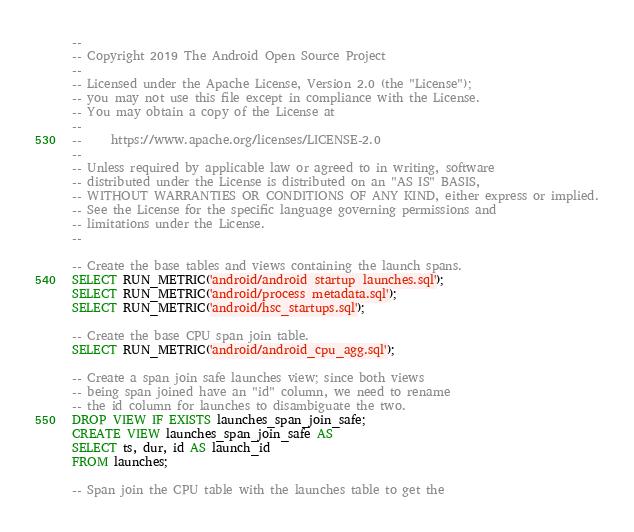<code> <loc_0><loc_0><loc_500><loc_500><_SQL_>--
-- Copyright 2019 The Android Open Source Project
--
-- Licensed under the Apache License, Version 2.0 (the "License");
-- you may not use this file except in compliance with the License.
-- You may obtain a copy of the License at
--
--     https://www.apache.org/licenses/LICENSE-2.0
--
-- Unless required by applicable law or agreed to in writing, software
-- distributed under the License is distributed on an "AS IS" BASIS,
-- WITHOUT WARRANTIES OR CONDITIONS OF ANY KIND, either express or implied.
-- See the License for the specific language governing permissions and
-- limitations under the License.
--

-- Create the base tables and views containing the launch spans.
SELECT RUN_METRIC('android/android_startup_launches.sql');
SELECT RUN_METRIC('android/process_metadata.sql');
SELECT RUN_METRIC('android/hsc_startups.sql');

-- Create the base CPU span join table.
SELECT RUN_METRIC('android/android_cpu_agg.sql');

-- Create a span join safe launches view; since both views
-- being span joined have an "id" column, we need to rename
-- the id column for launches to disambiguate the two.
DROP VIEW IF EXISTS launches_span_join_safe;
CREATE VIEW launches_span_join_safe AS
SELECT ts, dur, id AS launch_id
FROM launches;

-- Span join the CPU table with the launches table to get the</code> 